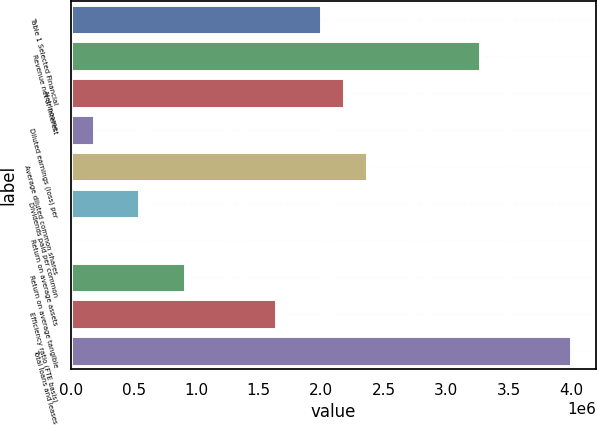<chart> <loc_0><loc_0><loc_500><loc_500><bar_chart><fcel>Table 1 Selected Financial<fcel>Revenue net of interest<fcel>Net income<fcel>Diluted earnings (loss) per<fcel>Average diluted common shares<fcel>Dividends paid per common<fcel>Return on average assets<fcel>Return on average tangible<fcel>Efficiency ratio (FTE basis)<fcel>Total loans and leases<nl><fcel>1.99974e+06<fcel>3.2723e+06<fcel>2.18153e+06<fcel>181794<fcel>2.36333e+06<fcel>545383<fcel>0.22<fcel>908972<fcel>1.63615e+06<fcel>3.99947e+06<nl></chart> 